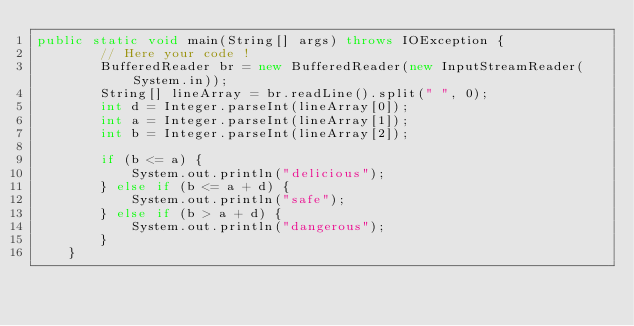<code> <loc_0><loc_0><loc_500><loc_500><_Java_>public static void main(String[] args) throws IOException {
        // Here your code !
        BufferedReader br = new BufferedReader(new InputStreamReader(System.in));
        String[] lineArray = br.readLine().split(" ", 0);
        int d = Integer.parseInt(lineArray[0]);
        int a = Integer.parseInt(lineArray[1]);
        int b = Integer.parseInt(lineArray[2]);

        if (b <= a) {
            System.out.println("delicious");
        } else if (b <= a + d) {
            System.out.println("safe");
        } else if (b > a + d) {
            System.out.println("dangerous");
        }
    }</code> 